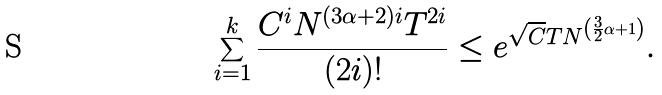Convert formula to latex. <formula><loc_0><loc_0><loc_500><loc_500>\sum _ { i = 1 } ^ { k } \frac { C ^ { i } N ^ { ( 3 \alpha + 2 ) i } T ^ { 2 i } } { ( 2 i ) ! } \leq e ^ { \sqrt { C } T N ^ { \left ( \frac { 3 } { 2 } \alpha + 1 \right ) } } .</formula> 